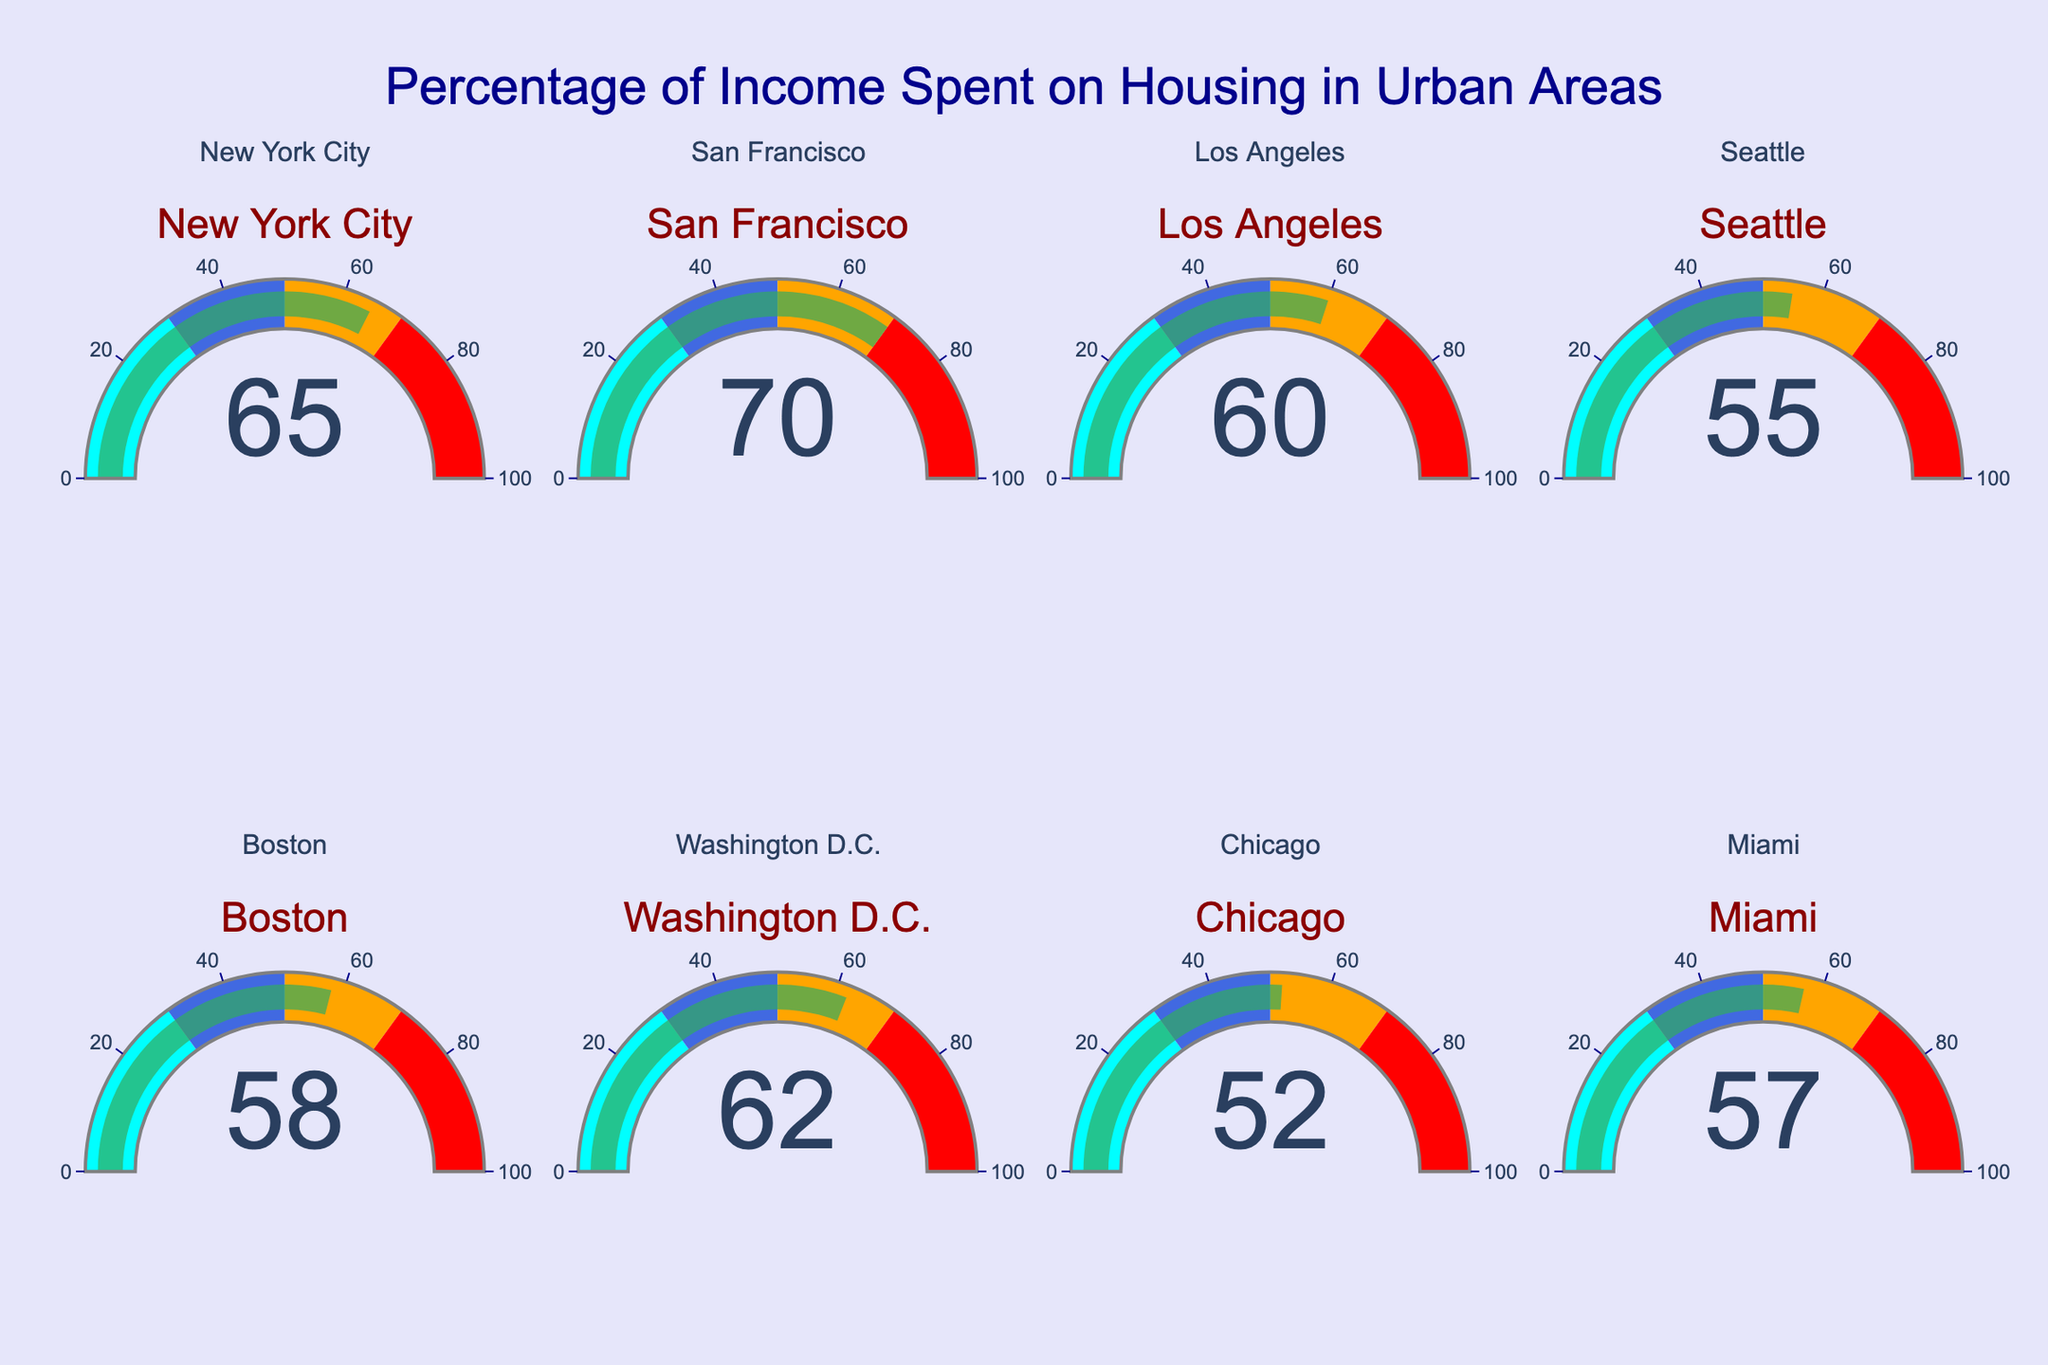What's the title of the figure? The title is typically displayed prominently at the top of the figure. In this case, it reads "Percentage of Income Spent on Housing in Urban Areas."
Answer: Percentage of Income Spent on Housing in Urban Areas Which city has the highest percentage of income spent on housing? To determine the highest percentage, look at each gauge's number and compare them. San Francisco has the highest value at 70%.
Answer: San Francisco Which city has the lowest percentage of income spent on housing? To find the lowest percentage, compare each gauge's number and identify the smallest value. Chicago has the lowest value at 52%.
Answer: Chicago What is the percentage of income spent on housing in Boston? Locate the Boston gauge and read the number displayed on it, which is 58%.
Answer: 58% How many cities have a percentage of income spent on housing above 60%? Identify and count the gauges with values above 60%. These cities are New York City, San Francisco, Washington D.C., and Los Angeles, making a total of 4.
Answer: 4 What is the average percentage of income spent on housing across all the cities? Sum all the percentages (65 + 70 + 60 + 55 + 58 + 62 + 52 + 57) and divide by the number of cities (8). The calculation is (479 / 8) = 59.875.
Answer: 59.875 How much more percentage of income is spent on housing in San Francisco compared to Seattle? Subtract the percentage for Seattle from that of San Francisco (70 - 55 = 15).
Answer: 15 Between Boston and Miami, which city has a higher percentage of income spent on housing and by how much? Compare the percentages for Boston (58%) and Miami (57%) and find the difference (58 - 57 = 1).
Answer: Boston, 1 Which cities fall within the range of 50% to 60% for income spent on housing? Identify the gauges with values within the range of 50% to 60%. These are Los Angeles, Seattle, Boston, Chicago, and Miami.
Answer: Los Angeles, Seattle, Boston, Chicago, Miami How does the gauge for Washington D.C. visually indicate the threshold of 80%? The threshold is indicated by a red line and the percentage value specified in the gauge's settings. Washington D.C.'s gauge shows the red line and the red number 80 but does not reach it.
Answer: Red line without reaching 80 